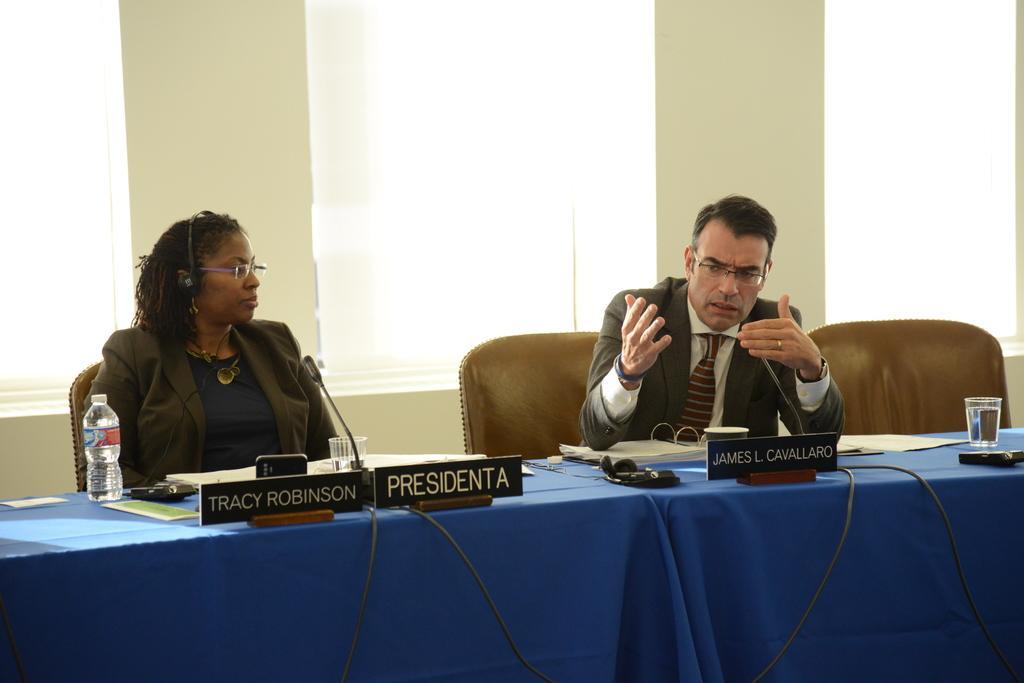Can you describe this image briefly? In this image there is a man and a woman sitting in chairs, beside them there is an empty chair, in front of them on the table there are mice, bottle of water, specs, mobile, name plates, cables and some other objects, behind them there are curtains on the windows, in between the windows there is a wall. 